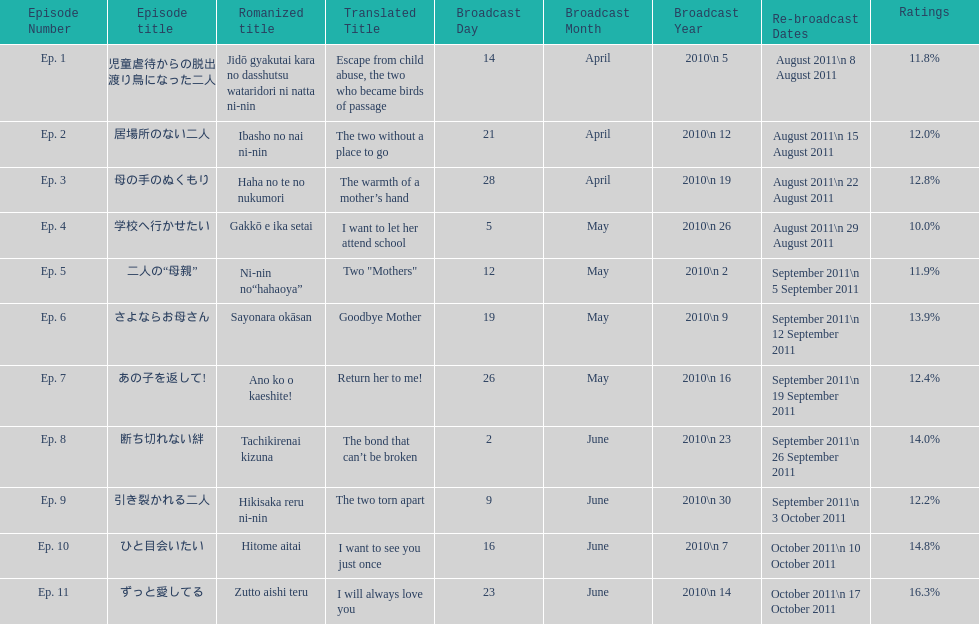What episode number was the only episode to have over 16% of ratings? 11. 